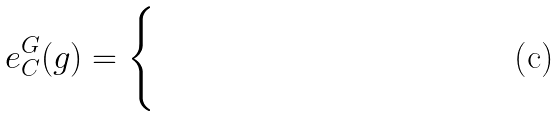<formula> <loc_0><loc_0><loc_500><loc_500>e ^ { G } _ { C } ( g ) = \begin{cases} & \quad \\ & \quad \\ \end{cases}</formula> 